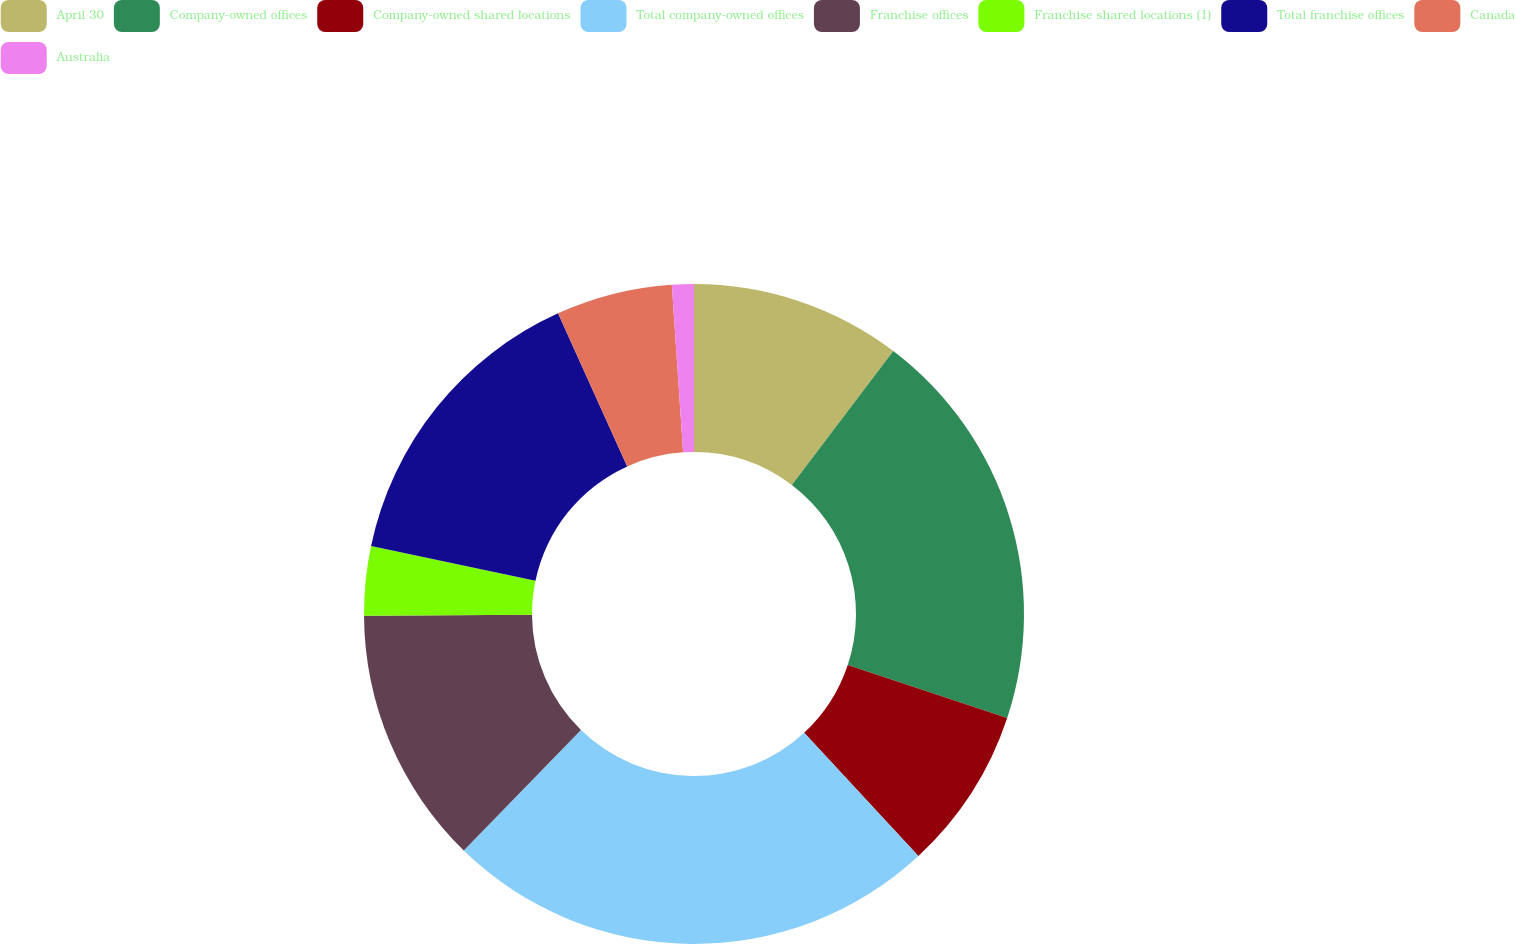Convert chart to OTSL. <chart><loc_0><loc_0><loc_500><loc_500><pie_chart><fcel>April 30<fcel>Company-owned offices<fcel>Company-owned shared locations<fcel>Total company-owned offices<fcel>Franchise offices<fcel>Franchise shared locations (1)<fcel>Total franchise offices<fcel>Canada<fcel>Australia<nl><fcel>10.32%<fcel>19.78%<fcel>8.0%<fcel>24.19%<fcel>12.63%<fcel>3.38%<fcel>14.94%<fcel>5.69%<fcel>1.07%<nl></chart> 